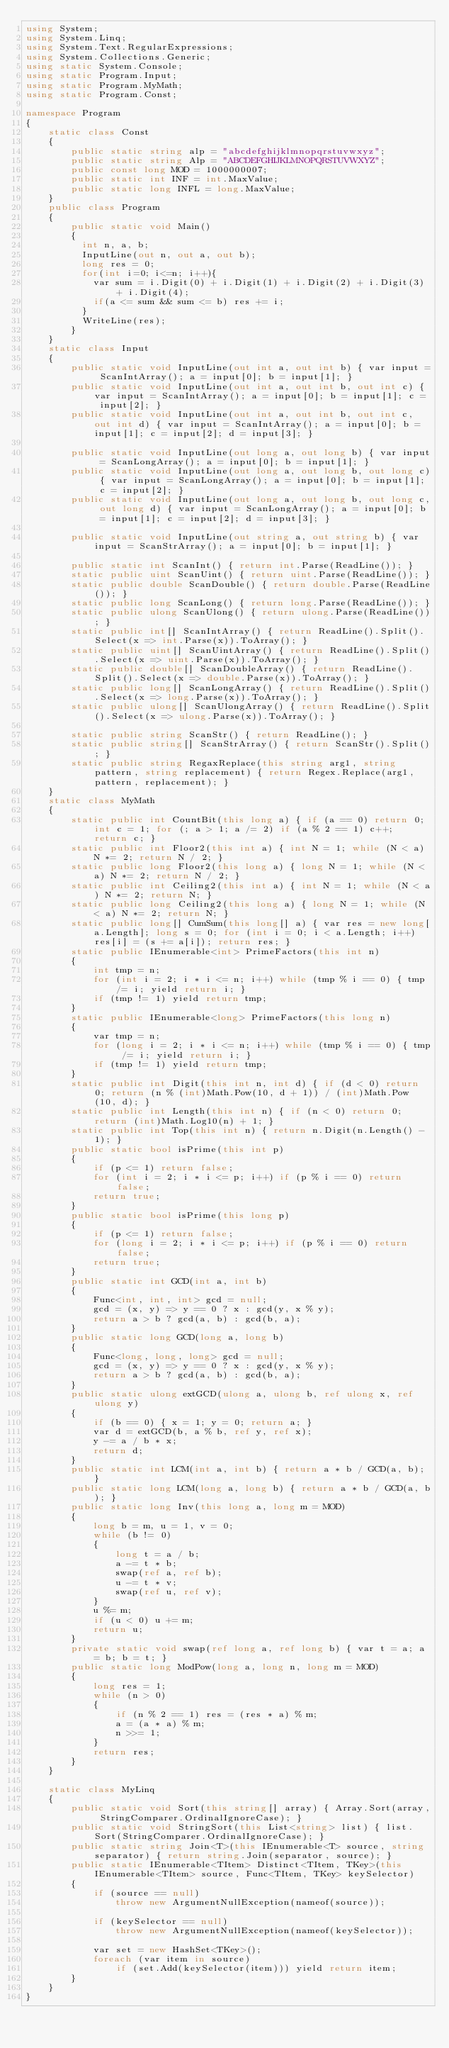<code> <loc_0><loc_0><loc_500><loc_500><_C#_>using System;
using System.Linq;
using System.Text.RegularExpressions;
using System.Collections.Generic;
using static System.Console;
using static Program.Input;
using static Program.MyMath;
using static Program.Const;

namespace Program
{
    static class Const
    {
        public static string alp = "abcdefghijklmnopqrstuvwxyz";
        public static string Alp = "ABCDEFGHIJKLMNOPQRSTUVWXYZ";
        public const long MOD = 1000000007;
        public static int INF = int.MaxValue;
        public static long INFL = long.MaxValue;
    }
    public class Program
    {
        public static void Main()
        {
          int n, a, b;
          InputLine(out n, out a, out b);
          long res = 0;
          for(int i=0; i<=n; i++){
            var sum = i.Digit(0) + i.Digit(1) + i.Digit(2) + i.Digit(3) + i.Digit(4);
            if(a <= sum && sum <= b) res += i;
          }
          WriteLine(res);
        }
    }
    static class Input
    {
        public static void InputLine(out int a, out int b) { var input = ScanIntArray(); a = input[0]; b = input[1]; }
        public static void InputLine(out int a, out int b, out int c) { var input = ScanIntArray(); a = input[0]; b = input[1]; c = input[2]; }
        public static void InputLine(out int a, out int b, out int c, out int d) { var input = ScanIntArray(); a = input[0]; b = input[1]; c = input[2]; d = input[3]; }

        public static void InputLine(out long a, out long b) { var input = ScanLongArray(); a = input[0]; b = input[1]; }
        public static void InputLine(out long a, out long b, out long c) { var input = ScanLongArray(); a = input[0]; b = input[1]; c = input[2]; }
        public static void InputLine(out long a, out long b, out long c, out long d) { var input = ScanLongArray(); a = input[0]; b = input[1]; c = input[2]; d = input[3]; }

        public static void InputLine(out string a, out string b) { var input = ScanStrArray(); a = input[0]; b = input[1]; }

        public static int ScanInt() { return int.Parse(ReadLine()); }
        static public uint ScanUint() { return uint.Parse(ReadLine()); }
        static public double ScanDouble() { return double.Parse(ReadLine()); }
        static public long ScanLong() { return long.Parse(ReadLine()); }
        static public ulong ScanUlong() { return ulong.Parse(ReadLine()); }
        static public int[] ScanIntArray() { return ReadLine().Split().Select(x => int.Parse(x)).ToArray(); }
        static public uint[] ScanUintArray() { return ReadLine().Split().Select(x => uint.Parse(x)).ToArray(); }
        static public double[] ScanDoubleArray() { return ReadLine().Split().Select(x => double.Parse(x)).ToArray(); }
        static public long[] ScanLongArray() { return ReadLine().Split().Select(x => long.Parse(x)).ToArray(); }
        static public ulong[] ScanUlongArray() { return ReadLine().Split().Select(x => ulong.Parse(x)).ToArray(); }

        static public string ScanStr() { return ReadLine(); }
        static public string[] ScanStrArray() { return ScanStr().Split(); }
        static public string RegaxReplace(this string arg1, string pattern, string replacement) { return Regex.Replace(arg1, pattern, replacement); }
    }
    static class MyMath
    {
        static public int CountBit(this long a) { if (a == 0) return 0; int c = 1; for (; a > 1; a /= 2) if (a % 2 == 1) c++; return c; }
        static public int Floor2(this int a) { int N = 1; while (N < a) N *= 2; return N / 2; }
        static public long Floor2(this long a) { long N = 1; while (N < a) N *= 2; return N / 2; }
        static public int Ceiling2(this int a) { int N = 1; while (N < a) N *= 2; return N; }
        static public long Ceiling2(this long a) { long N = 1; while (N < a) N *= 2; return N; }
        static public long[] CumSum(this long[] a) { var res = new long[a.Length]; long s = 0; for (int i = 0; i < a.Length; i++) res[i] = (s += a[i]); return res; }
        static public IEnumerable<int> PrimeFactors(this int n)
        {
            int tmp = n;
            for (int i = 2; i * i <= n; i++) while (tmp % i == 0) { tmp /= i; yield return i; }
            if (tmp != 1) yield return tmp;
        }
        static public IEnumerable<long> PrimeFactors(this long n)
        {
            var tmp = n;
            for (long i = 2; i * i <= n; i++) while (tmp % i == 0) { tmp /= i; yield return i; }
            if (tmp != 1) yield return tmp;
        }
        static public int Digit(this int n, int d) { if (d < 0) return 0; return (n % (int)Math.Pow(10, d + 1)) / (int)Math.Pow(10, d); }
        static public int Length(this int n) { if (n < 0) return 0; return (int)Math.Log10(n) + 1; }
        static public int Top(this int n) { return n.Digit(n.Length() - 1); }
        public static bool isPrime(this int p)
        {
            if (p <= 1) return false;
            for (int i = 2; i * i <= p; i++) if (p % i == 0) return false;
            return true;
        }
        public static bool isPrime(this long p)
        {
            if (p <= 1) return false;
            for (long i = 2; i * i <= p; i++) if (p % i == 0) return false;
            return true;
        }
        public static int GCD(int a, int b)
        {
            Func<int, int, int> gcd = null;
            gcd = (x, y) => y == 0 ? x : gcd(y, x % y);
            return a > b ? gcd(a, b) : gcd(b, a);
        }
        public static long GCD(long a, long b)
        {
            Func<long, long, long> gcd = null;
            gcd = (x, y) => y == 0 ? x : gcd(y, x % y);
            return a > b ? gcd(a, b) : gcd(b, a);
        }
        public static ulong extGCD(ulong a, ulong b, ref ulong x, ref ulong y)
        {
            if (b == 0) { x = 1; y = 0; return a; }
            var d = extGCD(b, a % b, ref y, ref x);
            y -= a / b * x;
            return d;
        }
        public static int LCM(int a, int b) { return a * b / GCD(a, b); }
        public static long LCM(long a, long b) { return a * b / GCD(a, b); }
        public static long Inv(this long a, long m = MOD)
        {
            long b = m, u = 1, v = 0;
            while (b != 0)
            {
                long t = a / b;
                a -= t * b;
                swap(ref a, ref b);
                u -= t * v;
                swap(ref u, ref v);
            }
            u %= m;
            if (u < 0) u += m;
            return u;
        }
        private static void swap(ref long a, ref long b) { var t = a; a = b; b = t; }
        public static long ModPow(long a, long n, long m = MOD)
        {
            long res = 1;
            while (n > 0)
            {
                if (n % 2 == 1) res = (res * a) % m;
                a = (a * a) % m;
                n >>= 1;
            }
            return res;
        }
    }

    static class MyLinq
    {
        public static void Sort(this string[] array) { Array.Sort(array, StringComparer.OrdinalIgnoreCase); }
        public static void StringSort(this List<string> list) { list.Sort(StringComparer.OrdinalIgnoreCase); }
        public static string Join<T>(this IEnumerable<T> source, string separator) { return string.Join(separator, source); }
        public static IEnumerable<TItem> Distinct<TItem, TKey>(this IEnumerable<TItem> source, Func<TItem, TKey> keySelector)
        {
            if (source == null)
                throw new ArgumentNullException(nameof(source));

            if (keySelector == null)
                throw new ArgumentNullException(nameof(keySelector));

            var set = new HashSet<TKey>();
            foreach (var item in source)
                if (set.Add(keySelector(item))) yield return item;
        }
    }
}
</code> 